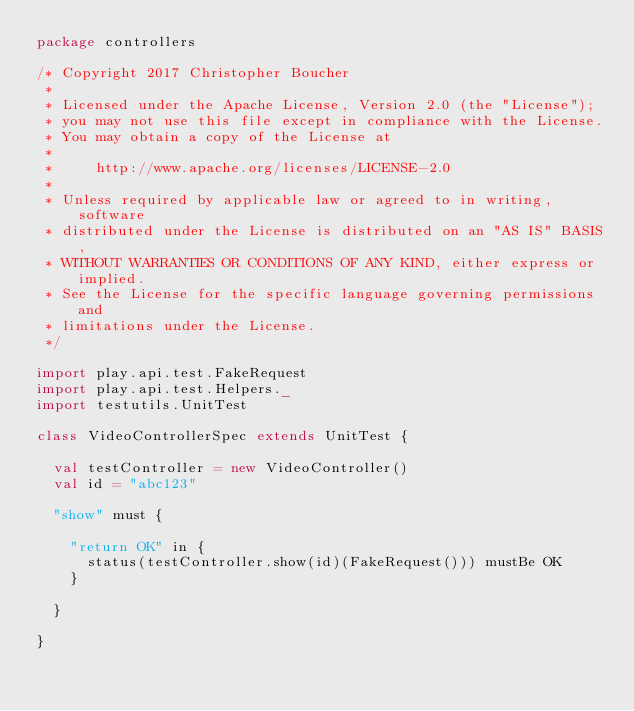Convert code to text. <code><loc_0><loc_0><loc_500><loc_500><_Scala_>package controllers

/* Copyright 2017 Christopher Boucher
 *
 * Licensed under the Apache License, Version 2.0 (the "License");
 * you may not use this file except in compliance with the License.
 * You may obtain a copy of the License at
 *
 *     http://www.apache.org/licenses/LICENSE-2.0
 *
 * Unless required by applicable law or agreed to in writing, software
 * distributed under the License is distributed on an "AS IS" BASIS,
 * WITHOUT WARRANTIES OR CONDITIONS OF ANY KIND, either express or implied.
 * See the License for the specific language governing permissions and
 * limitations under the License.
 */

import play.api.test.FakeRequest
import play.api.test.Helpers._
import testutils.UnitTest

class VideoControllerSpec extends UnitTest {

  val testController = new VideoController()
  val id = "abc123"

  "show" must {

    "return OK" in {
      status(testController.show(id)(FakeRequest())) mustBe OK
    }

  }

}
</code> 